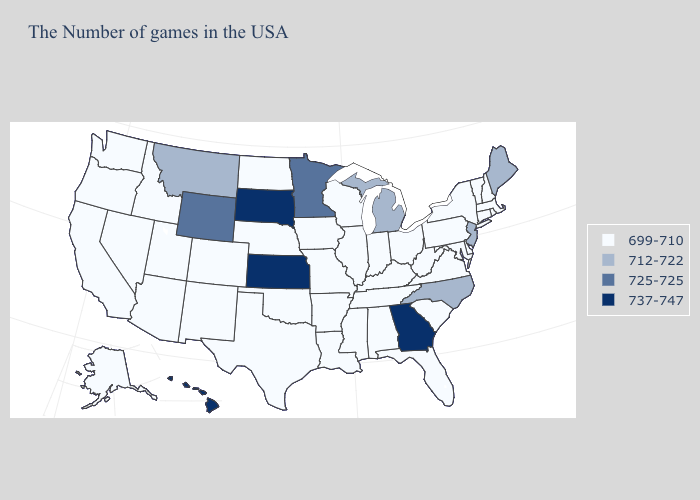Is the legend a continuous bar?
Concise answer only. No. Is the legend a continuous bar?
Quick response, please. No. What is the value of Louisiana?
Answer briefly. 699-710. Name the states that have a value in the range 725-725?
Write a very short answer. Minnesota, Wyoming. Which states have the highest value in the USA?
Quick response, please. Georgia, Kansas, South Dakota, Hawaii. What is the highest value in the West ?
Keep it brief. 737-747. Which states hav the highest value in the West?
Keep it brief. Hawaii. What is the highest value in states that border Tennessee?
Be succinct. 737-747. Does the map have missing data?
Quick response, please. No. Name the states that have a value in the range 737-747?
Short answer required. Georgia, Kansas, South Dakota, Hawaii. What is the value of Nebraska?
Give a very brief answer. 699-710. Name the states that have a value in the range 699-710?
Concise answer only. Massachusetts, Rhode Island, New Hampshire, Vermont, Connecticut, New York, Delaware, Maryland, Pennsylvania, Virginia, South Carolina, West Virginia, Ohio, Florida, Kentucky, Indiana, Alabama, Tennessee, Wisconsin, Illinois, Mississippi, Louisiana, Missouri, Arkansas, Iowa, Nebraska, Oklahoma, Texas, North Dakota, Colorado, New Mexico, Utah, Arizona, Idaho, Nevada, California, Washington, Oregon, Alaska. Name the states that have a value in the range 699-710?
Keep it brief. Massachusetts, Rhode Island, New Hampshire, Vermont, Connecticut, New York, Delaware, Maryland, Pennsylvania, Virginia, South Carolina, West Virginia, Ohio, Florida, Kentucky, Indiana, Alabama, Tennessee, Wisconsin, Illinois, Mississippi, Louisiana, Missouri, Arkansas, Iowa, Nebraska, Oklahoma, Texas, North Dakota, Colorado, New Mexico, Utah, Arizona, Idaho, Nevada, California, Washington, Oregon, Alaska. What is the value of Missouri?
Write a very short answer. 699-710. Name the states that have a value in the range 712-722?
Concise answer only. Maine, New Jersey, North Carolina, Michigan, Montana. 